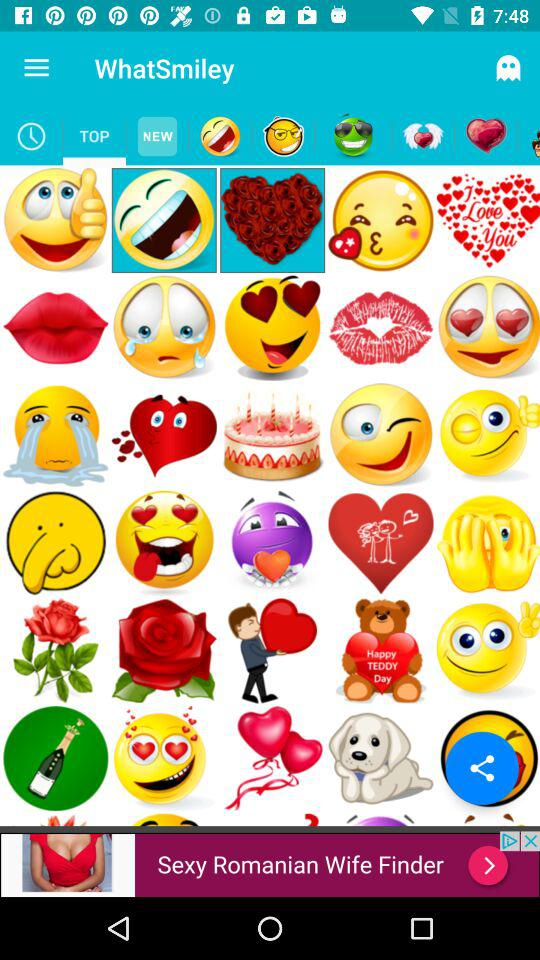What is the app name? The app name is "WhatSmiley". 